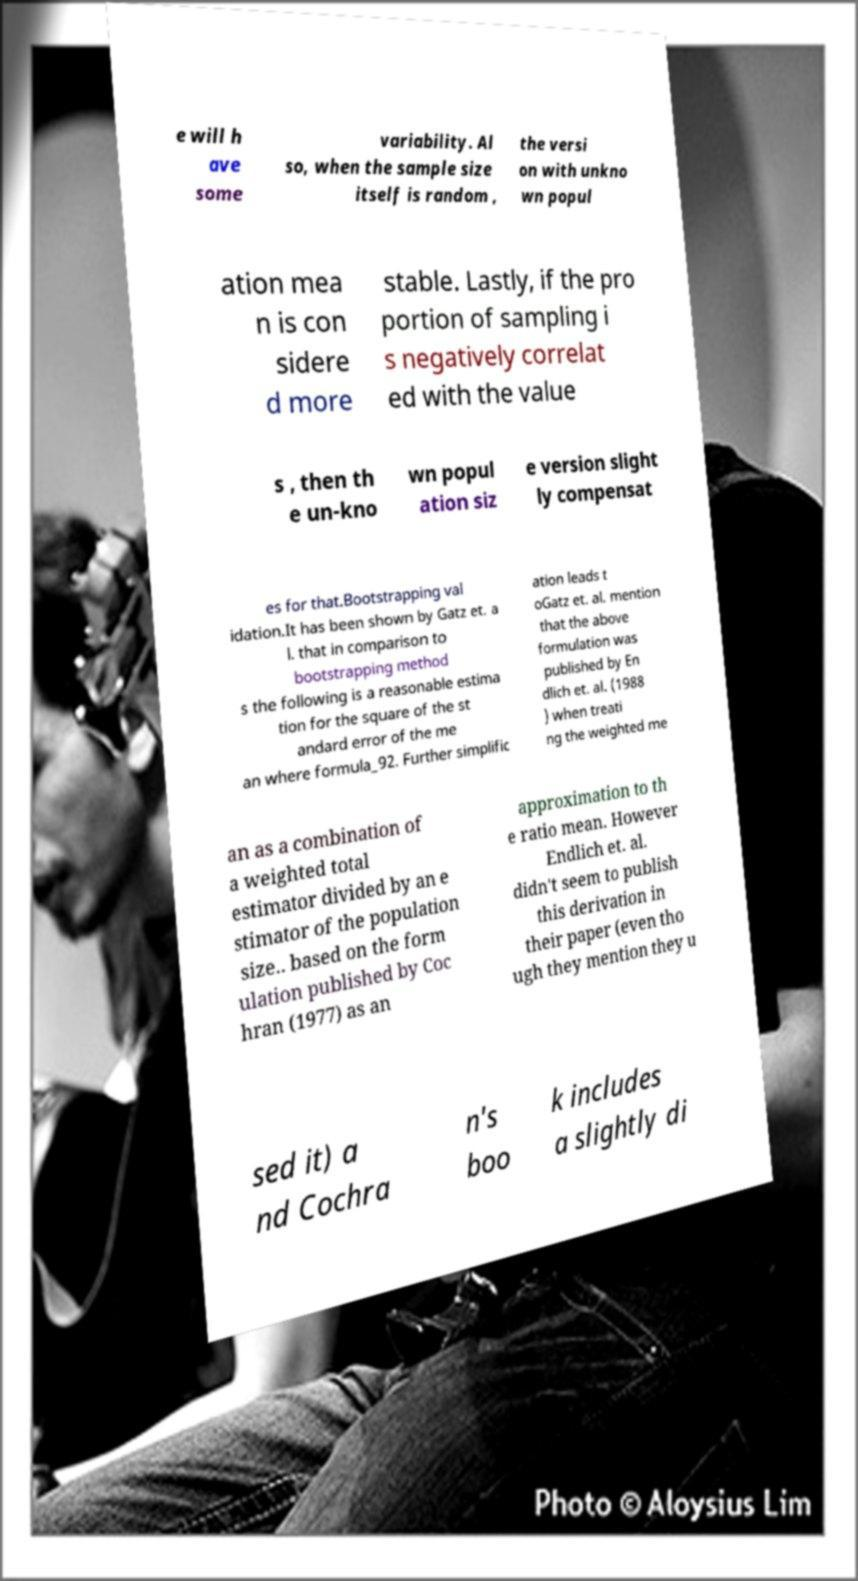Can you read and provide the text displayed in the image?This photo seems to have some interesting text. Can you extract and type it out for me? e will h ave some variability. Al so, when the sample size itself is random , the versi on with unkno wn popul ation mea n is con sidere d more stable. Lastly, if the pro portion of sampling i s negatively correlat ed with the value s , then th e un-kno wn popul ation siz e version slight ly compensat es for that.Bootstrapping val idation.It has been shown by Gatz et. a l. that in comparison to bootstrapping method s the following is a reasonable estima tion for the square of the st andard error of the me an where formula_92. Further simplific ation leads t oGatz et. al. mention that the above formulation was published by En dlich et. al. (1988 ) when treati ng the weighted me an as a combination of a weighted total estimator divided by an e stimator of the population size.. based on the form ulation published by Coc hran (1977) as an approximation to th e ratio mean. However Endlich et. al. didn't seem to publish this derivation in their paper (even tho ugh they mention they u sed it) a nd Cochra n's boo k includes a slightly di 